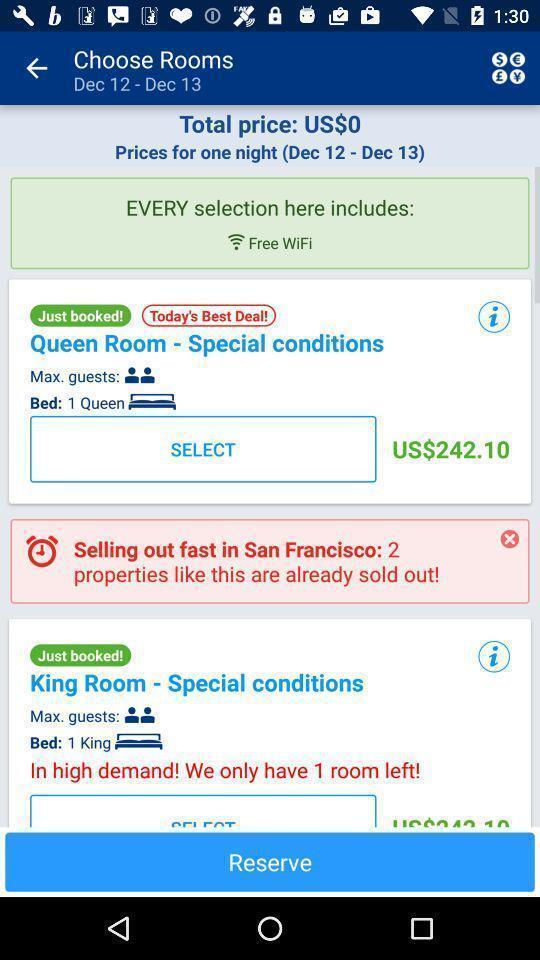Provide a description of this screenshot. Page displaying the multiple options. 